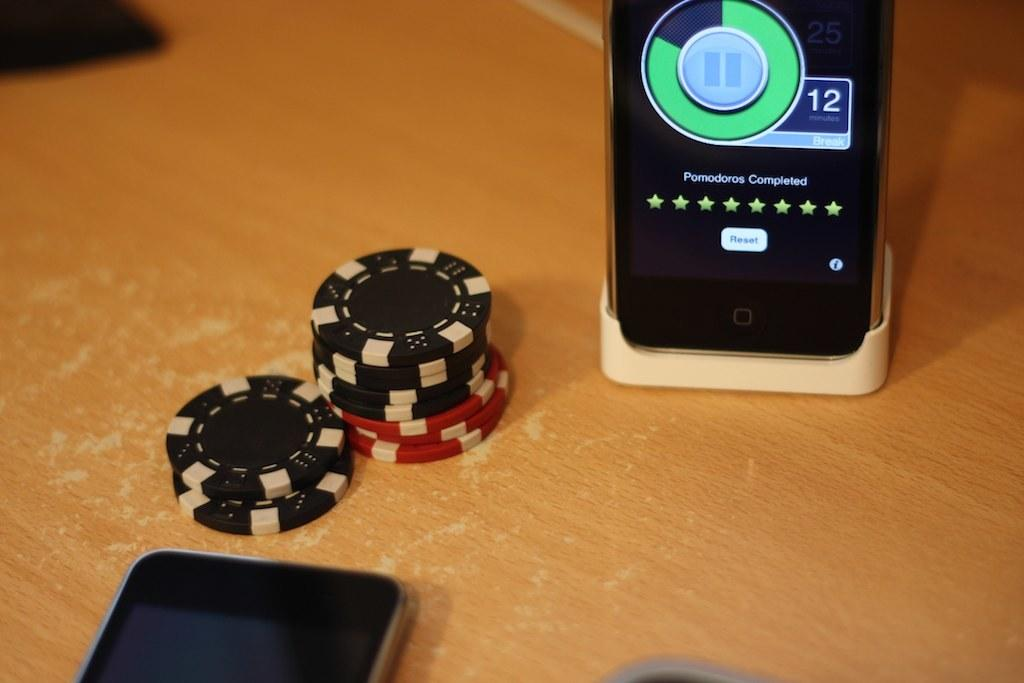<image>
Give a short and clear explanation of the subsequent image. A small stack of poker chips sit by a cellphone with the volume set to 12. 